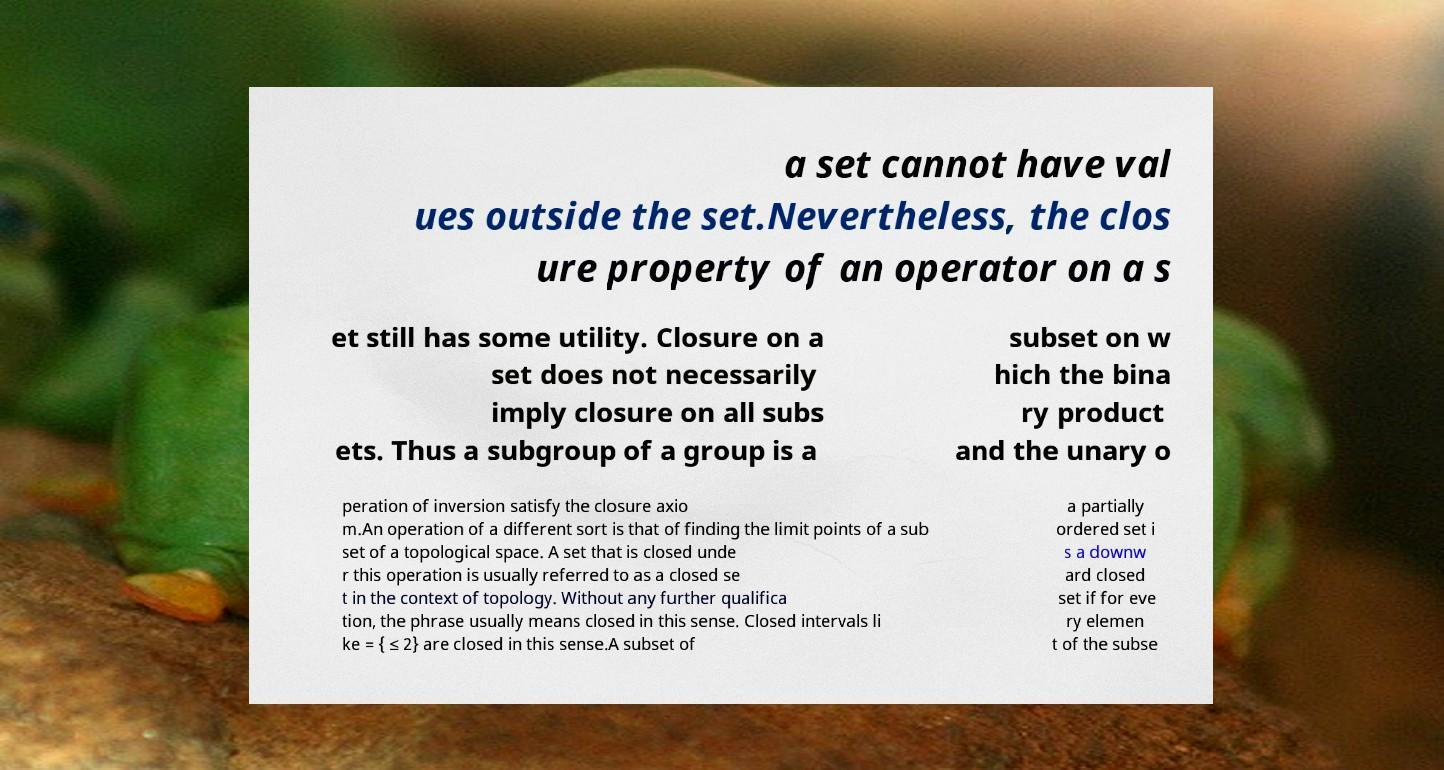For documentation purposes, I need the text within this image transcribed. Could you provide that? a set cannot have val ues outside the set.Nevertheless, the clos ure property of an operator on a s et still has some utility. Closure on a set does not necessarily imply closure on all subs ets. Thus a subgroup of a group is a subset on w hich the bina ry product and the unary o peration of inversion satisfy the closure axio m.An operation of a different sort is that of finding the limit points of a sub set of a topological space. A set that is closed unde r this operation is usually referred to as a closed se t in the context of topology. Without any further qualifica tion, the phrase usually means closed in this sense. Closed intervals li ke = { ≤ 2} are closed in this sense.A subset of a partially ordered set i s a downw ard closed set if for eve ry elemen t of the subse 